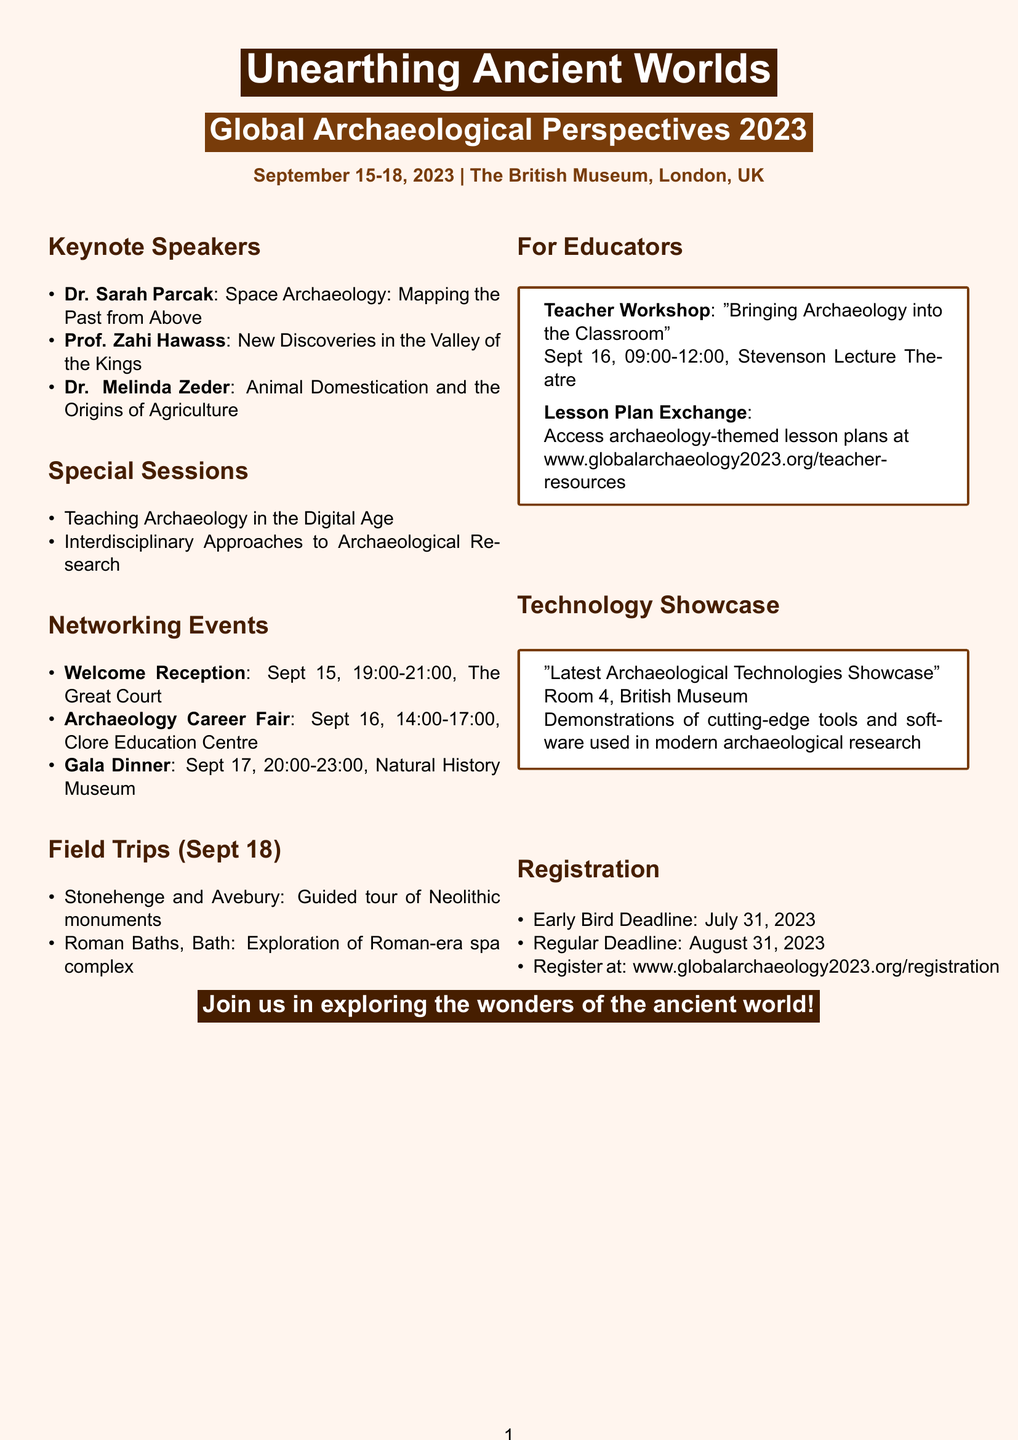What is the title of the conference? The title of the conference is explicitly stated in the document as "Unearthing Ancient Worlds: Global Archaeological Perspectives 2023."
Answer: Unearthing Ancient Worlds: Global Archaeological Perspectives 2023 Who is one of the keynote speakers? The document lists three keynote speakers, and any of their names can be a valid answer. For instance, Dr. Sarah Parcak is mentioned as one of them.
Answer: Dr. Sarah Parcak What is the date of the Welcome Reception? The date for the Welcome Reception is explicitly mentioned in the document.
Answer: September 15, 2023 What is the venue for the Gala Dinner? The venue for the Gala Dinner is clearly stated in the document.
Answer: Natural History Museum, Hintze Hall What time does the Teacher Workshop start? The starting time of the Teacher Workshop is specified in the document.
Answer: 09:00 What are the field trip destinations listed in the brochure? The document provides two field trip destinations, which can be referenced together.
Answer: Stonehenge and Avebury; Roman Baths, Bath How many days will the conference run? The conference dates clearly indicate how many days it will last, from September 15 to September 18, 2023.
Answer: Four days What is the purpose of the Lesson Plan Exchange? The document states the function of the Lesson Plan Exchange concerning resource sharing among educators.
Answer: Share and download archaeology-themed lesson plans What is the last day for regular registration? The last day for regular registration is explicitly stated in the document, offering clear information.
Answer: August 31, 2023 